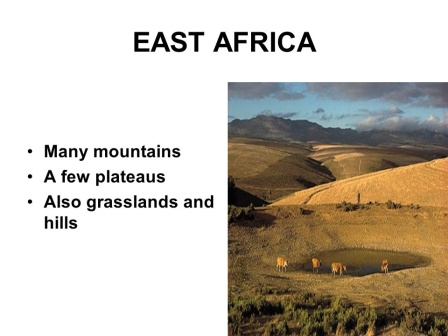Can you provide more details about the types of wildlife that might be found in this region? Beyond the elephants seen in the foreground, East Africa is home to a rich diversity of wildlife. In the grasslands and savannas, you might find majestic creatures like lions, cheetahs, and leopards, gracefully roaming in search of prey. In the sky, the graceful flight of African fish eagles and vultures adds to the dynamic ecosystem. The region's rivers and waterholes attract hippos and crocodiles, while antelopes, zebras, and wildebeests dot the plains, often seen in large herds. The diversity extends to smaller creatures like meerkats, warthogs, and a plethora of bird species that contribute to the region's vibrant natural symphony. 